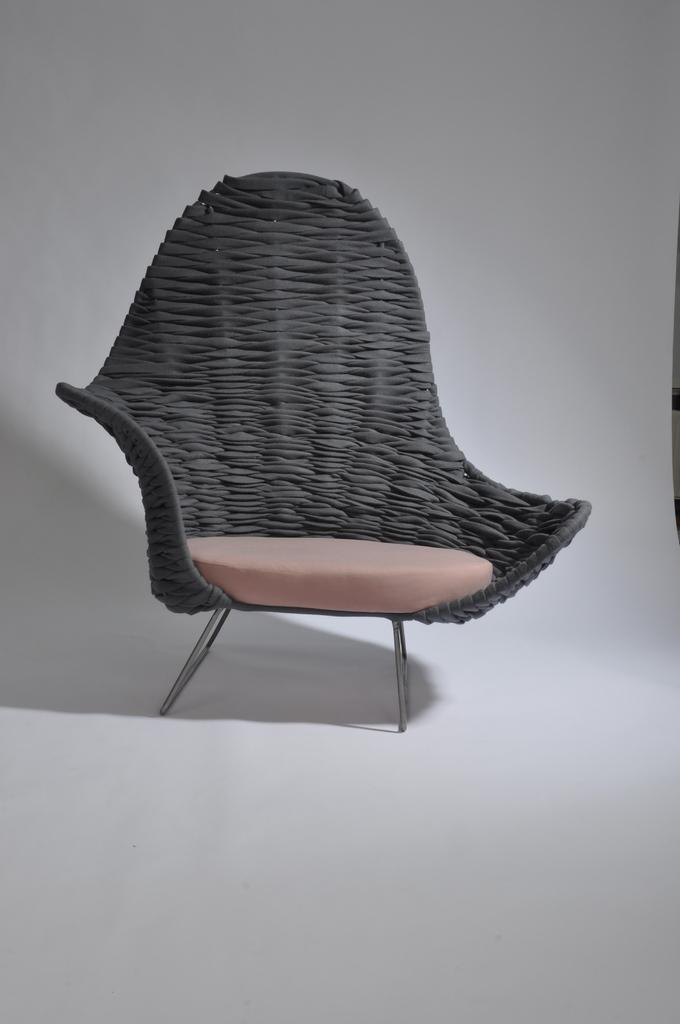What is the primary color of the paper in the image? The primary color of the paper in the image is white. What is depicted on the paper? There is a chair painting on the paper. Where is the nest located in the image? There is no nest present in the image. What type of wall is depicted in the image? The image does not show a wall; it features a white paper with a chair painting on it. 